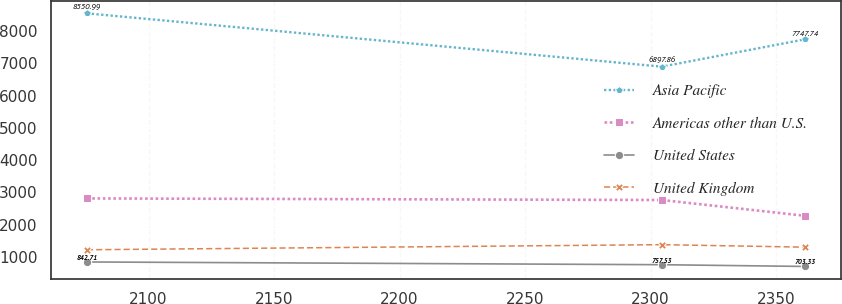<chart> <loc_0><loc_0><loc_500><loc_500><line_chart><ecel><fcel>Asia Pacific<fcel>Americas other than U.S.<fcel>United States<fcel>United Kingdom<nl><fcel>2075.47<fcel>8550.99<fcel>2812.45<fcel>842.71<fcel>1221.12<nl><fcel>2304.45<fcel>6897.86<fcel>2763.1<fcel>757.53<fcel>1379.1<nl><fcel>2361.66<fcel>7747.74<fcel>2272.65<fcel>703.33<fcel>1301.31<nl></chart> 